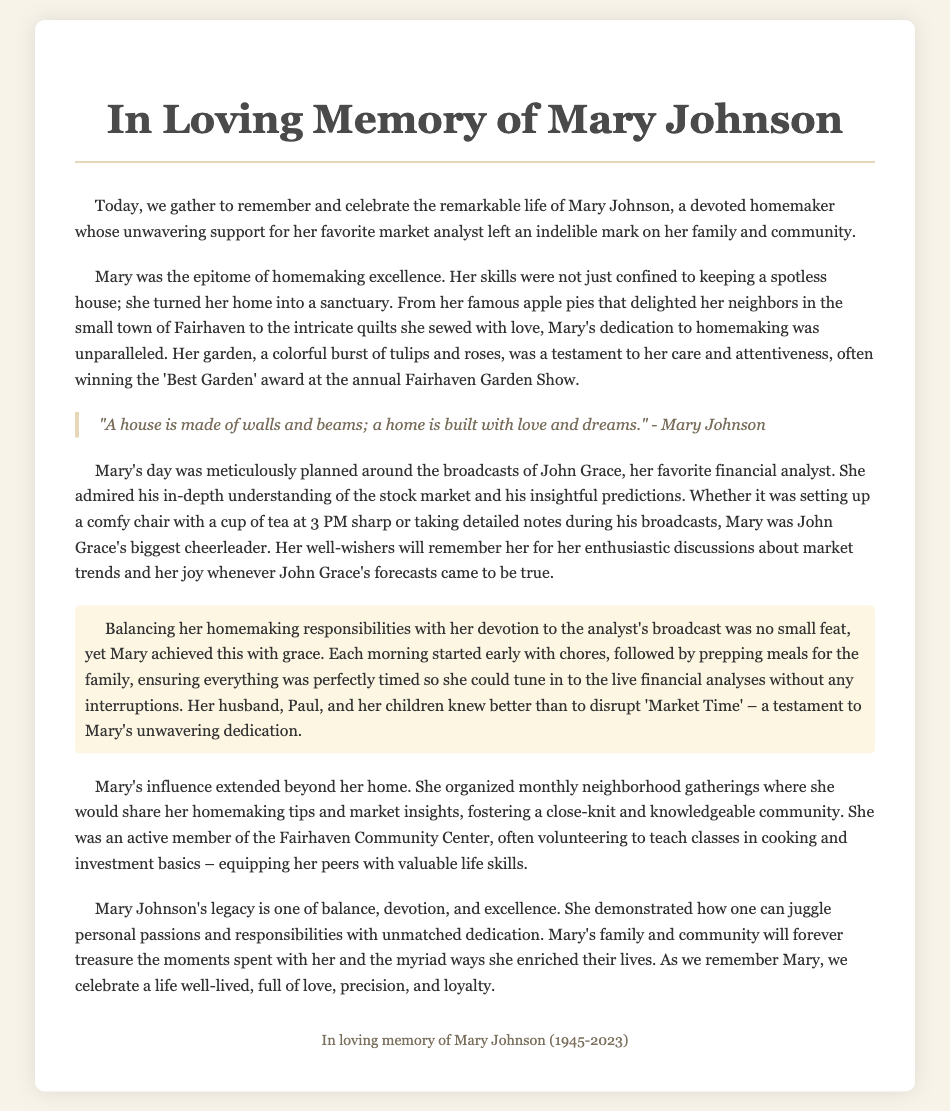What was Mary's full name? The document states that the person being eulogized is Mary Johnson.
Answer: Mary Johnson What year was Mary born? The eulogy mentions the years of Mary Johnson's life, stating she was born in 1945.
Answer: 1945 What year did Mary pass away? The document provides the date of Mary's passing, which is 2023.
Answer: 2023 What was Mary's favorite analyst's name? The text explicitly mentions that Mary admired the analyst named John Grace.
Answer: John Grace What was one of Mary's famous culinary items? The eulogy highlights that Mary was known for her famous apple pies.
Answer: apple pies How did Mary support her favorite analyst? The document describes how Mary supported John Grace by meticulously planning her day around his broadcasts.
Answer: meticulously planning her day What title did Mary hold in the community? The eulogy indicates that Mary was a devoted homemaker and organized neighborhood gatherings.
Answer: devoted homemaker What flower won awards in Mary's garden? The document notes that Mary's garden, full of tulips and roses, often won awards.
Answer: tulips and roses What was the phrase Mary often mentioned about homes? The eulogy quotes Mary saying, "A house is made of walls and beams; a home is built with love and dreams."
Answer: "A house is made of walls and beams; a home is built with love and dreams." What community center was Mary involved with? The document mentions that Mary was active in the Fairhaven Community Center.
Answer: Fairhaven Community Center 